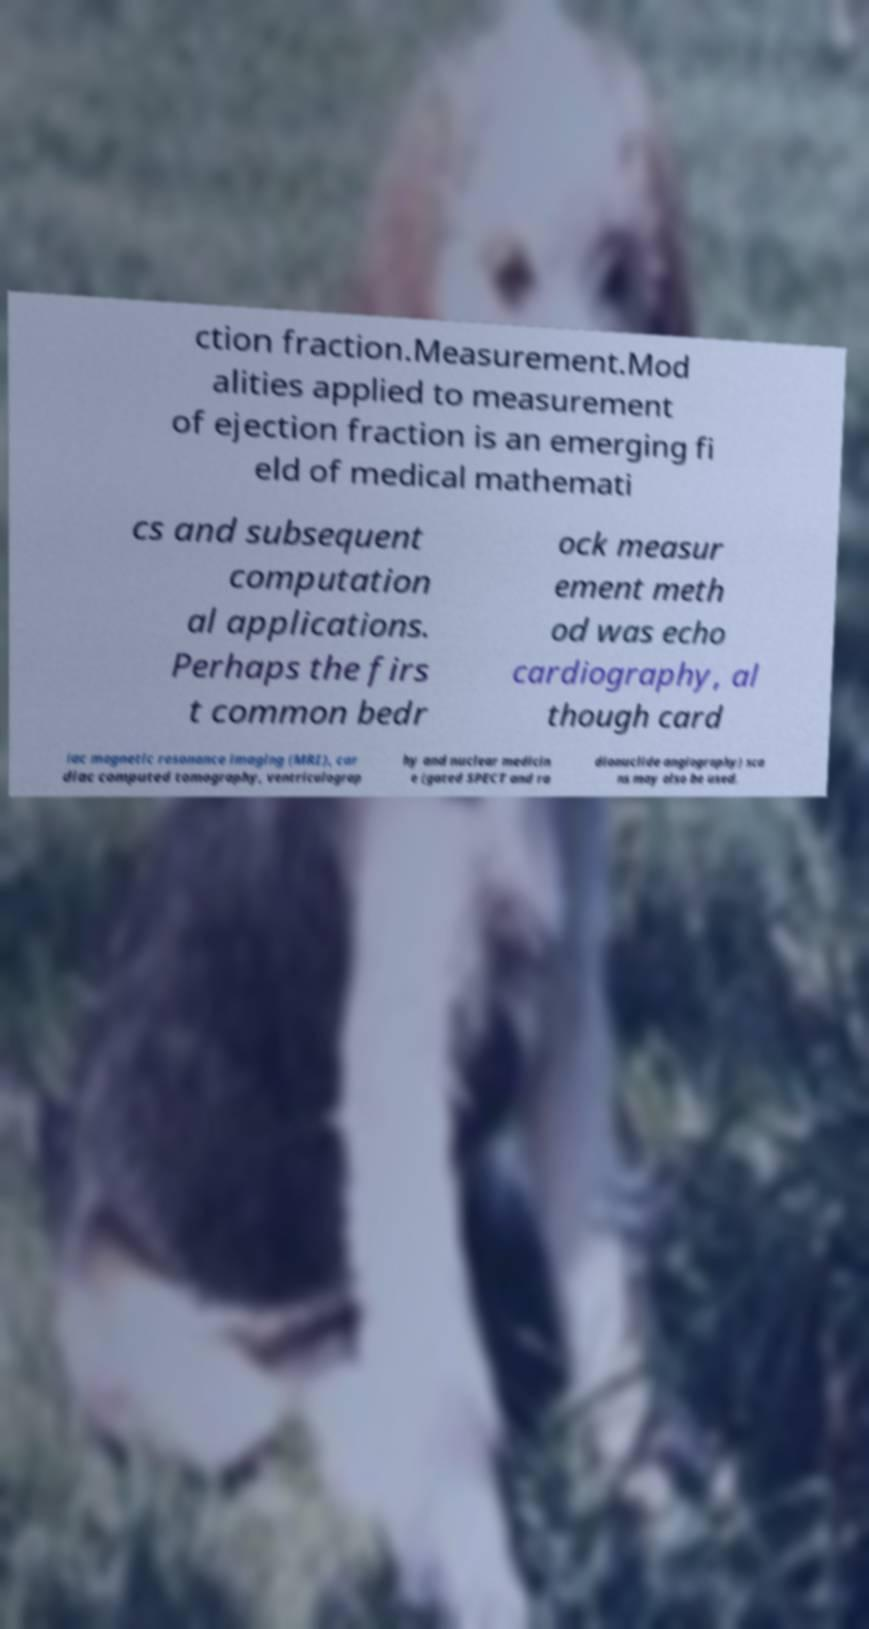Can you accurately transcribe the text from the provided image for me? ction fraction.Measurement.Mod alities applied to measurement of ejection fraction is an emerging fi eld of medical mathemati cs and subsequent computation al applications. Perhaps the firs t common bedr ock measur ement meth od was echo cardiography, al though card iac magnetic resonance imaging (MRI), car diac computed tomography, ventriculograp hy and nuclear medicin e (gated SPECT and ra dionuclide angiography) sca ns may also be used. 